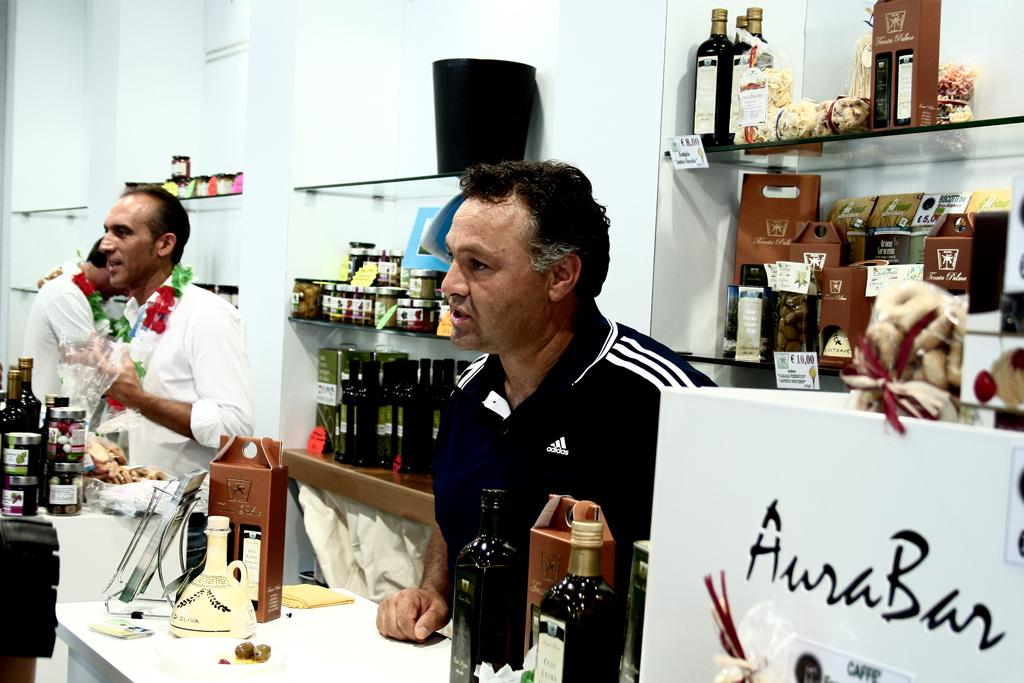<image>
Render a clear and concise summary of the photo. A man in a black and white Adidas shirt is standing behind the counter at market. 